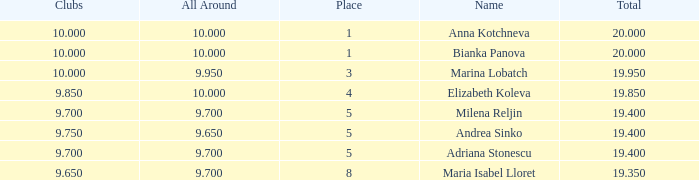What total has 10 as the clubs, with a place greater than 1? 19.95. 